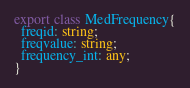Convert code to text. <code><loc_0><loc_0><loc_500><loc_500><_TypeScript_>export class MedFrequency{
  freqid: string;
  freqvalue: string;
  frequency_int: any;
}
</code> 